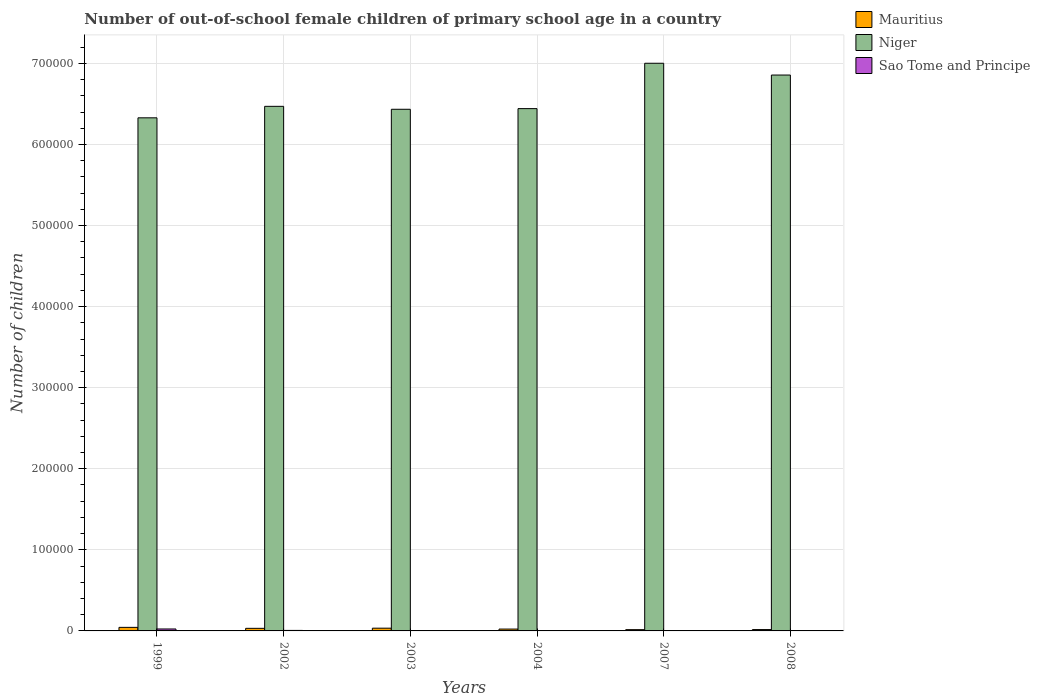Are the number of bars per tick equal to the number of legend labels?
Your response must be concise. Yes. Are the number of bars on each tick of the X-axis equal?
Offer a terse response. Yes. What is the label of the 5th group of bars from the left?
Ensure brevity in your answer.  2007. What is the number of out-of-school female children in Sao Tome and Principe in 2007?
Your response must be concise. 196. Across all years, what is the maximum number of out-of-school female children in Mauritius?
Your answer should be compact. 4393. Across all years, what is the minimum number of out-of-school female children in Mauritius?
Provide a succinct answer. 1575. What is the total number of out-of-school female children in Mauritius in the graph?
Provide a short and direct response. 1.65e+04. What is the difference between the number of out-of-school female children in Niger in 2004 and that in 2008?
Offer a very short reply. -4.14e+04. What is the difference between the number of out-of-school female children in Niger in 2003 and the number of out-of-school female children in Sao Tome and Principe in 1999?
Your answer should be compact. 6.41e+05. What is the average number of out-of-school female children in Sao Tome and Principe per year?
Provide a succinct answer. 628.17. In the year 1999, what is the difference between the number of out-of-school female children in Mauritius and number of out-of-school female children in Niger?
Your response must be concise. -6.28e+05. What is the ratio of the number of out-of-school female children in Sao Tome and Principe in 2004 to that in 2007?
Make the answer very short. 0.58. Is the number of out-of-school female children in Niger in 2007 less than that in 2008?
Your response must be concise. No. What is the difference between the highest and the second highest number of out-of-school female children in Mauritius?
Offer a very short reply. 1002. What is the difference between the highest and the lowest number of out-of-school female children in Mauritius?
Provide a short and direct response. 2818. Is the sum of the number of out-of-school female children in Mauritius in 2003 and 2004 greater than the maximum number of out-of-school female children in Sao Tome and Principe across all years?
Make the answer very short. Yes. What does the 1st bar from the left in 2002 represents?
Offer a terse response. Mauritius. What does the 2nd bar from the right in 2008 represents?
Your answer should be very brief. Niger. Is it the case that in every year, the sum of the number of out-of-school female children in Mauritius and number of out-of-school female children in Sao Tome and Principe is greater than the number of out-of-school female children in Niger?
Your response must be concise. No. How many bars are there?
Make the answer very short. 18. How many years are there in the graph?
Keep it short and to the point. 6. Does the graph contain any zero values?
Your response must be concise. No. What is the title of the graph?
Give a very brief answer. Number of out-of-school female children of primary school age in a country. What is the label or title of the Y-axis?
Offer a very short reply. Number of children. What is the Number of children in Mauritius in 1999?
Ensure brevity in your answer.  4393. What is the Number of children of Niger in 1999?
Provide a succinct answer. 6.33e+05. What is the Number of children in Sao Tome and Principe in 1999?
Provide a succinct answer. 2408. What is the Number of children of Mauritius in 2002?
Your answer should be compact. 3198. What is the Number of children of Niger in 2002?
Your answer should be very brief. 6.47e+05. What is the Number of children of Sao Tome and Principe in 2002?
Your response must be concise. 621. What is the Number of children of Mauritius in 2003?
Your answer should be very brief. 3391. What is the Number of children of Niger in 2003?
Ensure brevity in your answer.  6.43e+05. What is the Number of children in Sao Tome and Principe in 2003?
Your response must be concise. 379. What is the Number of children in Mauritius in 2004?
Provide a short and direct response. 2278. What is the Number of children of Niger in 2004?
Make the answer very short. 6.44e+05. What is the Number of children of Sao Tome and Principe in 2004?
Your answer should be very brief. 113. What is the Number of children of Mauritius in 2007?
Ensure brevity in your answer.  1575. What is the Number of children in Niger in 2007?
Offer a very short reply. 7.00e+05. What is the Number of children of Sao Tome and Principe in 2007?
Give a very brief answer. 196. What is the Number of children of Mauritius in 2008?
Ensure brevity in your answer.  1662. What is the Number of children in Niger in 2008?
Give a very brief answer. 6.86e+05. What is the Number of children of Sao Tome and Principe in 2008?
Keep it short and to the point. 52. Across all years, what is the maximum Number of children of Mauritius?
Provide a short and direct response. 4393. Across all years, what is the maximum Number of children in Niger?
Your answer should be very brief. 7.00e+05. Across all years, what is the maximum Number of children in Sao Tome and Principe?
Provide a succinct answer. 2408. Across all years, what is the minimum Number of children of Mauritius?
Your answer should be very brief. 1575. Across all years, what is the minimum Number of children in Niger?
Make the answer very short. 6.33e+05. Across all years, what is the minimum Number of children of Sao Tome and Principe?
Keep it short and to the point. 52. What is the total Number of children of Mauritius in the graph?
Provide a short and direct response. 1.65e+04. What is the total Number of children of Niger in the graph?
Provide a succinct answer. 3.95e+06. What is the total Number of children in Sao Tome and Principe in the graph?
Give a very brief answer. 3769. What is the difference between the Number of children in Mauritius in 1999 and that in 2002?
Keep it short and to the point. 1195. What is the difference between the Number of children in Niger in 1999 and that in 2002?
Offer a terse response. -1.42e+04. What is the difference between the Number of children of Sao Tome and Principe in 1999 and that in 2002?
Your answer should be very brief. 1787. What is the difference between the Number of children in Mauritius in 1999 and that in 2003?
Your response must be concise. 1002. What is the difference between the Number of children in Niger in 1999 and that in 2003?
Offer a terse response. -1.05e+04. What is the difference between the Number of children in Sao Tome and Principe in 1999 and that in 2003?
Ensure brevity in your answer.  2029. What is the difference between the Number of children in Mauritius in 1999 and that in 2004?
Your answer should be compact. 2115. What is the difference between the Number of children in Niger in 1999 and that in 2004?
Provide a succinct answer. -1.14e+04. What is the difference between the Number of children of Sao Tome and Principe in 1999 and that in 2004?
Keep it short and to the point. 2295. What is the difference between the Number of children in Mauritius in 1999 and that in 2007?
Offer a terse response. 2818. What is the difference between the Number of children in Niger in 1999 and that in 2007?
Offer a terse response. -6.73e+04. What is the difference between the Number of children in Sao Tome and Principe in 1999 and that in 2007?
Offer a terse response. 2212. What is the difference between the Number of children in Mauritius in 1999 and that in 2008?
Your response must be concise. 2731. What is the difference between the Number of children in Niger in 1999 and that in 2008?
Your response must be concise. -5.28e+04. What is the difference between the Number of children in Sao Tome and Principe in 1999 and that in 2008?
Provide a short and direct response. 2356. What is the difference between the Number of children of Mauritius in 2002 and that in 2003?
Give a very brief answer. -193. What is the difference between the Number of children of Niger in 2002 and that in 2003?
Give a very brief answer. 3627. What is the difference between the Number of children of Sao Tome and Principe in 2002 and that in 2003?
Keep it short and to the point. 242. What is the difference between the Number of children in Mauritius in 2002 and that in 2004?
Ensure brevity in your answer.  920. What is the difference between the Number of children of Niger in 2002 and that in 2004?
Provide a succinct answer. 2810. What is the difference between the Number of children in Sao Tome and Principe in 2002 and that in 2004?
Ensure brevity in your answer.  508. What is the difference between the Number of children in Mauritius in 2002 and that in 2007?
Provide a succinct answer. 1623. What is the difference between the Number of children of Niger in 2002 and that in 2007?
Your answer should be compact. -5.31e+04. What is the difference between the Number of children of Sao Tome and Principe in 2002 and that in 2007?
Give a very brief answer. 425. What is the difference between the Number of children in Mauritius in 2002 and that in 2008?
Make the answer very short. 1536. What is the difference between the Number of children of Niger in 2002 and that in 2008?
Your response must be concise. -3.86e+04. What is the difference between the Number of children in Sao Tome and Principe in 2002 and that in 2008?
Make the answer very short. 569. What is the difference between the Number of children of Mauritius in 2003 and that in 2004?
Provide a succinct answer. 1113. What is the difference between the Number of children in Niger in 2003 and that in 2004?
Your response must be concise. -817. What is the difference between the Number of children in Sao Tome and Principe in 2003 and that in 2004?
Give a very brief answer. 266. What is the difference between the Number of children of Mauritius in 2003 and that in 2007?
Your response must be concise. 1816. What is the difference between the Number of children in Niger in 2003 and that in 2007?
Give a very brief answer. -5.68e+04. What is the difference between the Number of children in Sao Tome and Principe in 2003 and that in 2007?
Keep it short and to the point. 183. What is the difference between the Number of children of Mauritius in 2003 and that in 2008?
Offer a very short reply. 1729. What is the difference between the Number of children in Niger in 2003 and that in 2008?
Ensure brevity in your answer.  -4.22e+04. What is the difference between the Number of children of Sao Tome and Principe in 2003 and that in 2008?
Ensure brevity in your answer.  327. What is the difference between the Number of children of Mauritius in 2004 and that in 2007?
Keep it short and to the point. 703. What is the difference between the Number of children in Niger in 2004 and that in 2007?
Offer a very short reply. -5.59e+04. What is the difference between the Number of children in Sao Tome and Principe in 2004 and that in 2007?
Provide a short and direct response. -83. What is the difference between the Number of children of Mauritius in 2004 and that in 2008?
Your response must be concise. 616. What is the difference between the Number of children of Niger in 2004 and that in 2008?
Provide a succinct answer. -4.14e+04. What is the difference between the Number of children of Mauritius in 2007 and that in 2008?
Your response must be concise. -87. What is the difference between the Number of children of Niger in 2007 and that in 2008?
Offer a terse response. 1.45e+04. What is the difference between the Number of children of Sao Tome and Principe in 2007 and that in 2008?
Your answer should be very brief. 144. What is the difference between the Number of children of Mauritius in 1999 and the Number of children of Niger in 2002?
Your answer should be very brief. -6.43e+05. What is the difference between the Number of children of Mauritius in 1999 and the Number of children of Sao Tome and Principe in 2002?
Make the answer very short. 3772. What is the difference between the Number of children of Niger in 1999 and the Number of children of Sao Tome and Principe in 2002?
Your answer should be very brief. 6.32e+05. What is the difference between the Number of children in Mauritius in 1999 and the Number of children in Niger in 2003?
Your answer should be compact. -6.39e+05. What is the difference between the Number of children in Mauritius in 1999 and the Number of children in Sao Tome and Principe in 2003?
Provide a succinct answer. 4014. What is the difference between the Number of children of Niger in 1999 and the Number of children of Sao Tome and Principe in 2003?
Give a very brief answer. 6.32e+05. What is the difference between the Number of children in Mauritius in 1999 and the Number of children in Niger in 2004?
Your answer should be very brief. -6.40e+05. What is the difference between the Number of children in Mauritius in 1999 and the Number of children in Sao Tome and Principe in 2004?
Provide a succinct answer. 4280. What is the difference between the Number of children in Niger in 1999 and the Number of children in Sao Tome and Principe in 2004?
Provide a succinct answer. 6.33e+05. What is the difference between the Number of children of Mauritius in 1999 and the Number of children of Niger in 2007?
Your answer should be very brief. -6.96e+05. What is the difference between the Number of children in Mauritius in 1999 and the Number of children in Sao Tome and Principe in 2007?
Give a very brief answer. 4197. What is the difference between the Number of children in Niger in 1999 and the Number of children in Sao Tome and Principe in 2007?
Make the answer very short. 6.33e+05. What is the difference between the Number of children of Mauritius in 1999 and the Number of children of Niger in 2008?
Give a very brief answer. -6.81e+05. What is the difference between the Number of children of Mauritius in 1999 and the Number of children of Sao Tome and Principe in 2008?
Your answer should be compact. 4341. What is the difference between the Number of children of Niger in 1999 and the Number of children of Sao Tome and Principe in 2008?
Provide a succinct answer. 6.33e+05. What is the difference between the Number of children of Mauritius in 2002 and the Number of children of Niger in 2003?
Provide a succinct answer. -6.40e+05. What is the difference between the Number of children in Mauritius in 2002 and the Number of children in Sao Tome and Principe in 2003?
Make the answer very short. 2819. What is the difference between the Number of children of Niger in 2002 and the Number of children of Sao Tome and Principe in 2003?
Keep it short and to the point. 6.47e+05. What is the difference between the Number of children in Mauritius in 2002 and the Number of children in Niger in 2004?
Provide a succinct answer. -6.41e+05. What is the difference between the Number of children in Mauritius in 2002 and the Number of children in Sao Tome and Principe in 2004?
Give a very brief answer. 3085. What is the difference between the Number of children in Niger in 2002 and the Number of children in Sao Tome and Principe in 2004?
Give a very brief answer. 6.47e+05. What is the difference between the Number of children in Mauritius in 2002 and the Number of children in Niger in 2007?
Your response must be concise. -6.97e+05. What is the difference between the Number of children in Mauritius in 2002 and the Number of children in Sao Tome and Principe in 2007?
Your response must be concise. 3002. What is the difference between the Number of children of Niger in 2002 and the Number of children of Sao Tome and Principe in 2007?
Give a very brief answer. 6.47e+05. What is the difference between the Number of children in Mauritius in 2002 and the Number of children in Niger in 2008?
Offer a terse response. -6.82e+05. What is the difference between the Number of children in Mauritius in 2002 and the Number of children in Sao Tome and Principe in 2008?
Give a very brief answer. 3146. What is the difference between the Number of children in Niger in 2002 and the Number of children in Sao Tome and Principe in 2008?
Your answer should be compact. 6.47e+05. What is the difference between the Number of children in Mauritius in 2003 and the Number of children in Niger in 2004?
Keep it short and to the point. -6.41e+05. What is the difference between the Number of children of Mauritius in 2003 and the Number of children of Sao Tome and Principe in 2004?
Make the answer very short. 3278. What is the difference between the Number of children of Niger in 2003 and the Number of children of Sao Tome and Principe in 2004?
Ensure brevity in your answer.  6.43e+05. What is the difference between the Number of children of Mauritius in 2003 and the Number of children of Niger in 2007?
Give a very brief answer. -6.97e+05. What is the difference between the Number of children in Mauritius in 2003 and the Number of children in Sao Tome and Principe in 2007?
Offer a very short reply. 3195. What is the difference between the Number of children in Niger in 2003 and the Number of children in Sao Tome and Principe in 2007?
Keep it short and to the point. 6.43e+05. What is the difference between the Number of children in Mauritius in 2003 and the Number of children in Niger in 2008?
Give a very brief answer. -6.82e+05. What is the difference between the Number of children of Mauritius in 2003 and the Number of children of Sao Tome and Principe in 2008?
Ensure brevity in your answer.  3339. What is the difference between the Number of children of Niger in 2003 and the Number of children of Sao Tome and Principe in 2008?
Offer a very short reply. 6.43e+05. What is the difference between the Number of children in Mauritius in 2004 and the Number of children in Niger in 2007?
Offer a terse response. -6.98e+05. What is the difference between the Number of children in Mauritius in 2004 and the Number of children in Sao Tome and Principe in 2007?
Offer a terse response. 2082. What is the difference between the Number of children in Niger in 2004 and the Number of children in Sao Tome and Principe in 2007?
Provide a succinct answer. 6.44e+05. What is the difference between the Number of children of Mauritius in 2004 and the Number of children of Niger in 2008?
Offer a very short reply. -6.83e+05. What is the difference between the Number of children in Mauritius in 2004 and the Number of children in Sao Tome and Principe in 2008?
Your answer should be compact. 2226. What is the difference between the Number of children of Niger in 2004 and the Number of children of Sao Tome and Principe in 2008?
Give a very brief answer. 6.44e+05. What is the difference between the Number of children in Mauritius in 2007 and the Number of children in Niger in 2008?
Give a very brief answer. -6.84e+05. What is the difference between the Number of children in Mauritius in 2007 and the Number of children in Sao Tome and Principe in 2008?
Offer a very short reply. 1523. What is the difference between the Number of children of Niger in 2007 and the Number of children of Sao Tome and Principe in 2008?
Provide a succinct answer. 7.00e+05. What is the average Number of children in Mauritius per year?
Your response must be concise. 2749.5. What is the average Number of children in Niger per year?
Your response must be concise. 6.59e+05. What is the average Number of children of Sao Tome and Principe per year?
Your answer should be compact. 628.17. In the year 1999, what is the difference between the Number of children in Mauritius and Number of children in Niger?
Ensure brevity in your answer.  -6.28e+05. In the year 1999, what is the difference between the Number of children of Mauritius and Number of children of Sao Tome and Principe?
Offer a very short reply. 1985. In the year 1999, what is the difference between the Number of children of Niger and Number of children of Sao Tome and Principe?
Provide a short and direct response. 6.30e+05. In the year 2002, what is the difference between the Number of children in Mauritius and Number of children in Niger?
Give a very brief answer. -6.44e+05. In the year 2002, what is the difference between the Number of children in Mauritius and Number of children in Sao Tome and Principe?
Provide a short and direct response. 2577. In the year 2002, what is the difference between the Number of children in Niger and Number of children in Sao Tome and Principe?
Your answer should be compact. 6.46e+05. In the year 2003, what is the difference between the Number of children in Mauritius and Number of children in Niger?
Provide a succinct answer. -6.40e+05. In the year 2003, what is the difference between the Number of children in Mauritius and Number of children in Sao Tome and Principe?
Keep it short and to the point. 3012. In the year 2003, what is the difference between the Number of children in Niger and Number of children in Sao Tome and Principe?
Your answer should be very brief. 6.43e+05. In the year 2004, what is the difference between the Number of children of Mauritius and Number of children of Niger?
Your answer should be compact. -6.42e+05. In the year 2004, what is the difference between the Number of children in Mauritius and Number of children in Sao Tome and Principe?
Ensure brevity in your answer.  2165. In the year 2004, what is the difference between the Number of children of Niger and Number of children of Sao Tome and Principe?
Provide a succinct answer. 6.44e+05. In the year 2007, what is the difference between the Number of children in Mauritius and Number of children in Niger?
Ensure brevity in your answer.  -6.99e+05. In the year 2007, what is the difference between the Number of children in Mauritius and Number of children in Sao Tome and Principe?
Your response must be concise. 1379. In the year 2007, what is the difference between the Number of children in Niger and Number of children in Sao Tome and Principe?
Make the answer very short. 7.00e+05. In the year 2008, what is the difference between the Number of children of Mauritius and Number of children of Niger?
Give a very brief answer. -6.84e+05. In the year 2008, what is the difference between the Number of children in Mauritius and Number of children in Sao Tome and Principe?
Offer a very short reply. 1610. In the year 2008, what is the difference between the Number of children of Niger and Number of children of Sao Tome and Principe?
Offer a very short reply. 6.86e+05. What is the ratio of the Number of children of Mauritius in 1999 to that in 2002?
Provide a succinct answer. 1.37. What is the ratio of the Number of children of Niger in 1999 to that in 2002?
Offer a terse response. 0.98. What is the ratio of the Number of children in Sao Tome and Principe in 1999 to that in 2002?
Your response must be concise. 3.88. What is the ratio of the Number of children of Mauritius in 1999 to that in 2003?
Provide a short and direct response. 1.3. What is the ratio of the Number of children of Niger in 1999 to that in 2003?
Give a very brief answer. 0.98. What is the ratio of the Number of children of Sao Tome and Principe in 1999 to that in 2003?
Your response must be concise. 6.35. What is the ratio of the Number of children in Mauritius in 1999 to that in 2004?
Provide a succinct answer. 1.93. What is the ratio of the Number of children in Niger in 1999 to that in 2004?
Your response must be concise. 0.98. What is the ratio of the Number of children in Sao Tome and Principe in 1999 to that in 2004?
Provide a short and direct response. 21.31. What is the ratio of the Number of children in Mauritius in 1999 to that in 2007?
Make the answer very short. 2.79. What is the ratio of the Number of children in Niger in 1999 to that in 2007?
Keep it short and to the point. 0.9. What is the ratio of the Number of children of Sao Tome and Principe in 1999 to that in 2007?
Offer a very short reply. 12.29. What is the ratio of the Number of children in Mauritius in 1999 to that in 2008?
Ensure brevity in your answer.  2.64. What is the ratio of the Number of children of Niger in 1999 to that in 2008?
Provide a short and direct response. 0.92. What is the ratio of the Number of children of Sao Tome and Principe in 1999 to that in 2008?
Offer a very short reply. 46.31. What is the ratio of the Number of children of Mauritius in 2002 to that in 2003?
Ensure brevity in your answer.  0.94. What is the ratio of the Number of children of Niger in 2002 to that in 2003?
Your answer should be compact. 1.01. What is the ratio of the Number of children in Sao Tome and Principe in 2002 to that in 2003?
Keep it short and to the point. 1.64. What is the ratio of the Number of children in Mauritius in 2002 to that in 2004?
Keep it short and to the point. 1.4. What is the ratio of the Number of children of Sao Tome and Principe in 2002 to that in 2004?
Your response must be concise. 5.5. What is the ratio of the Number of children of Mauritius in 2002 to that in 2007?
Keep it short and to the point. 2.03. What is the ratio of the Number of children of Niger in 2002 to that in 2007?
Provide a short and direct response. 0.92. What is the ratio of the Number of children of Sao Tome and Principe in 2002 to that in 2007?
Give a very brief answer. 3.17. What is the ratio of the Number of children in Mauritius in 2002 to that in 2008?
Offer a terse response. 1.92. What is the ratio of the Number of children in Niger in 2002 to that in 2008?
Ensure brevity in your answer.  0.94. What is the ratio of the Number of children of Sao Tome and Principe in 2002 to that in 2008?
Offer a terse response. 11.94. What is the ratio of the Number of children of Mauritius in 2003 to that in 2004?
Provide a short and direct response. 1.49. What is the ratio of the Number of children in Sao Tome and Principe in 2003 to that in 2004?
Offer a terse response. 3.35. What is the ratio of the Number of children of Mauritius in 2003 to that in 2007?
Offer a very short reply. 2.15. What is the ratio of the Number of children of Niger in 2003 to that in 2007?
Provide a short and direct response. 0.92. What is the ratio of the Number of children of Sao Tome and Principe in 2003 to that in 2007?
Offer a terse response. 1.93. What is the ratio of the Number of children in Mauritius in 2003 to that in 2008?
Provide a short and direct response. 2.04. What is the ratio of the Number of children in Niger in 2003 to that in 2008?
Your answer should be very brief. 0.94. What is the ratio of the Number of children in Sao Tome and Principe in 2003 to that in 2008?
Ensure brevity in your answer.  7.29. What is the ratio of the Number of children in Mauritius in 2004 to that in 2007?
Keep it short and to the point. 1.45. What is the ratio of the Number of children in Niger in 2004 to that in 2007?
Offer a terse response. 0.92. What is the ratio of the Number of children in Sao Tome and Principe in 2004 to that in 2007?
Provide a short and direct response. 0.58. What is the ratio of the Number of children of Mauritius in 2004 to that in 2008?
Offer a terse response. 1.37. What is the ratio of the Number of children of Niger in 2004 to that in 2008?
Your response must be concise. 0.94. What is the ratio of the Number of children in Sao Tome and Principe in 2004 to that in 2008?
Your answer should be very brief. 2.17. What is the ratio of the Number of children in Mauritius in 2007 to that in 2008?
Keep it short and to the point. 0.95. What is the ratio of the Number of children in Niger in 2007 to that in 2008?
Ensure brevity in your answer.  1.02. What is the ratio of the Number of children of Sao Tome and Principe in 2007 to that in 2008?
Ensure brevity in your answer.  3.77. What is the difference between the highest and the second highest Number of children of Mauritius?
Your response must be concise. 1002. What is the difference between the highest and the second highest Number of children in Niger?
Your answer should be compact. 1.45e+04. What is the difference between the highest and the second highest Number of children in Sao Tome and Principe?
Provide a succinct answer. 1787. What is the difference between the highest and the lowest Number of children in Mauritius?
Your response must be concise. 2818. What is the difference between the highest and the lowest Number of children of Niger?
Provide a short and direct response. 6.73e+04. What is the difference between the highest and the lowest Number of children in Sao Tome and Principe?
Ensure brevity in your answer.  2356. 